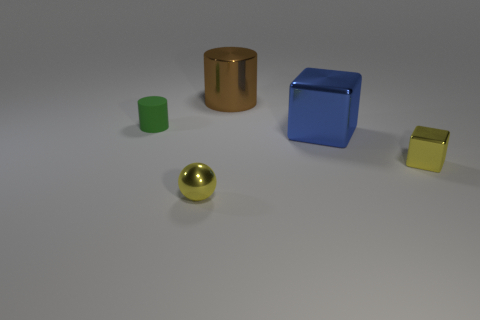Is there any other thing that has the same material as the small cylinder?
Ensure brevity in your answer.  No. There is a block that is the same color as the tiny sphere; what is its material?
Offer a very short reply. Metal. Does the green rubber thing have the same size as the brown shiny object?
Offer a very short reply. No. What number of objects are blue cubes or cylinders behind the small green cylinder?
Provide a short and direct response. 2. What is the material of the cube that is the same size as the green rubber cylinder?
Keep it short and to the point. Metal. There is a thing that is in front of the blue thing and right of the big brown cylinder; what material is it made of?
Your response must be concise. Metal. Are there any yellow things behind the tiny metal block that is in front of the green rubber object?
Ensure brevity in your answer.  No. What size is the thing that is behind the yellow metal block and on the right side of the big brown cylinder?
Keep it short and to the point. Large. What number of green objects are cylinders or tiny blocks?
Your answer should be compact. 1. The object that is the same size as the blue cube is what shape?
Give a very brief answer. Cylinder. 